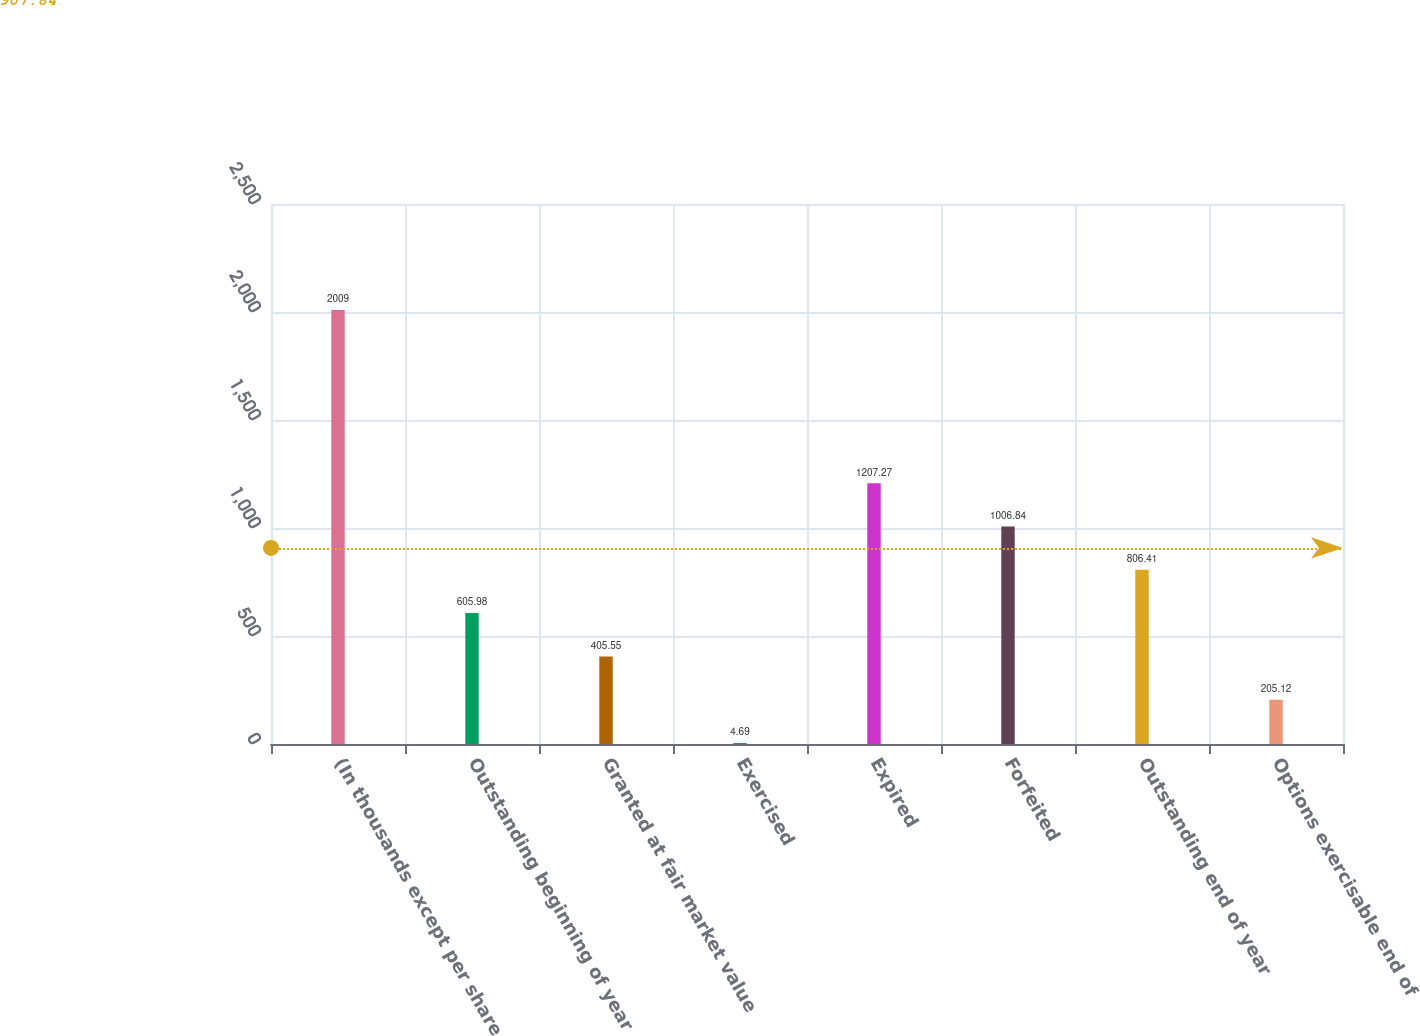<chart> <loc_0><loc_0><loc_500><loc_500><bar_chart><fcel>(In thousands except per share<fcel>Outstanding beginning of year<fcel>Granted at fair market value<fcel>Exercised<fcel>Expired<fcel>Forfeited<fcel>Outstanding end of year<fcel>Options exercisable end of<nl><fcel>2009<fcel>605.98<fcel>405.55<fcel>4.69<fcel>1207.27<fcel>1006.84<fcel>806.41<fcel>205.12<nl></chart> 